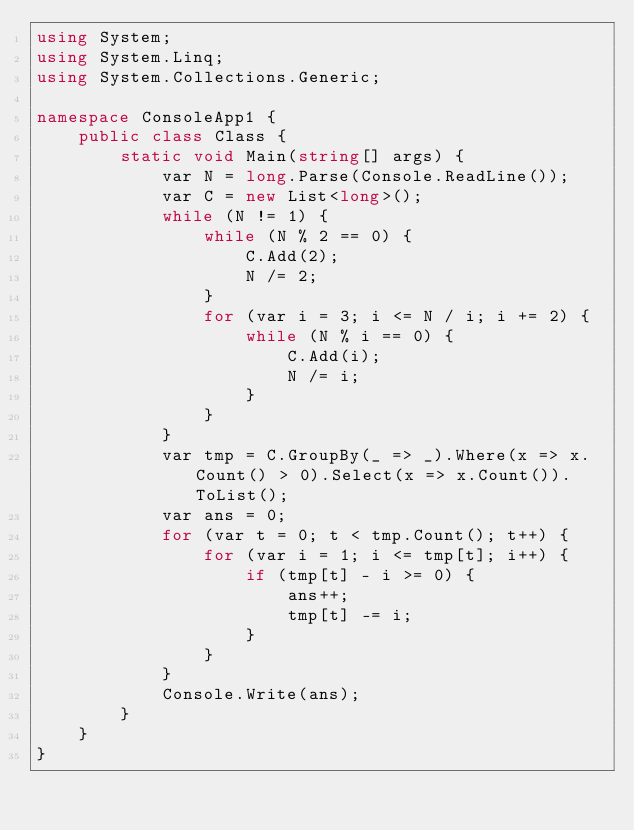Convert code to text. <code><loc_0><loc_0><loc_500><loc_500><_C#_>using System;
using System.Linq;
using System.Collections.Generic;

namespace ConsoleApp1 {
    public class Class {
        static void Main(string[] args) {
            var N = long.Parse(Console.ReadLine());
            var C = new List<long>();
            while (N != 1) {
                while (N % 2 == 0) {
                    C.Add(2);
                    N /= 2;
                }
                for (var i = 3; i <= N / i; i += 2) {
                    while (N % i == 0) {
                        C.Add(i);
                        N /= i;
                    }
                }
            }
            var tmp = C.GroupBy(_ => _).Where(x => x.Count() > 0).Select(x => x.Count()).ToList();
            var ans = 0;
            for (var t = 0; t < tmp.Count(); t++) {
                for (var i = 1; i <= tmp[t]; i++) {
                    if (tmp[t] - i >= 0) {
                        ans++;
                        tmp[t] -= i;
                    }
                }
            }
            Console.Write(ans);
        }
    }
}</code> 